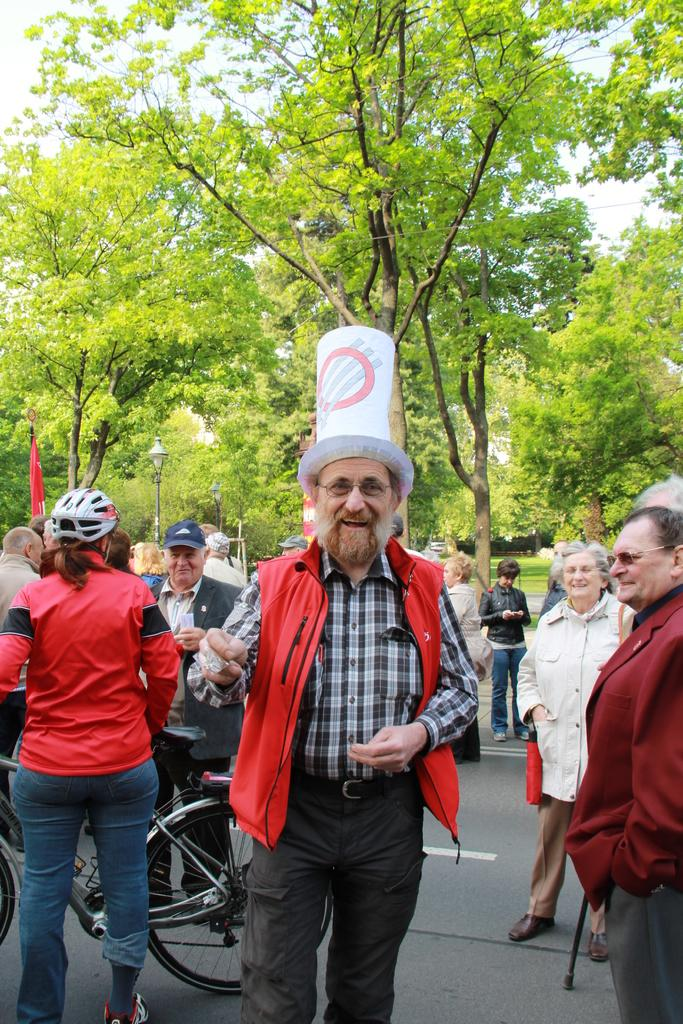How many people are in the image? There is a group of people in the image. What can be seen in the background of the image? There are trees and sky visible in the background of the image. What is the person holding in the image? There is a person holding a bicycle in the image. What type of road is shown in the image? The image shows a road. What type of headgear is worn by one of the people in the image? There is a person wearing a helmet and another person wearing a cap in the image. How many waves can be seen crashing on the shore in the image? There are no waves visible in the image; it shows a group of people, trees, sky, a road, and a person holding a bicycle. 